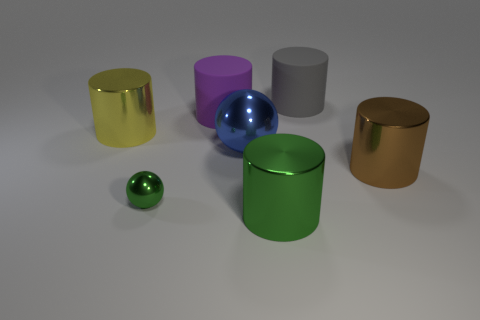There is a metallic ball in front of the big brown metal cylinder; how big is it?
Give a very brief answer. Small. What is the material of the yellow thing?
Provide a succinct answer. Metal. There is a rubber object on the left side of the rubber cylinder on the right side of the big blue ball; what shape is it?
Give a very brief answer. Cylinder. What number of other things are there of the same shape as the large green thing?
Offer a terse response. 4. There is a yellow metal object; are there any blue shiny balls on the right side of it?
Your answer should be very brief. Yes. What color is the small metal object?
Offer a terse response. Green. Does the tiny object have the same color as the large shiny cylinder that is in front of the small thing?
Your answer should be compact. Yes. Is there a brown object that has the same size as the yellow thing?
Keep it short and to the point. Yes. There is a big cylinder to the right of the gray matte thing; what is its material?
Offer a very short reply. Metal. Are there the same number of big blue shiny objects on the right side of the large blue shiny object and spheres in front of the small green sphere?
Make the answer very short. Yes. 